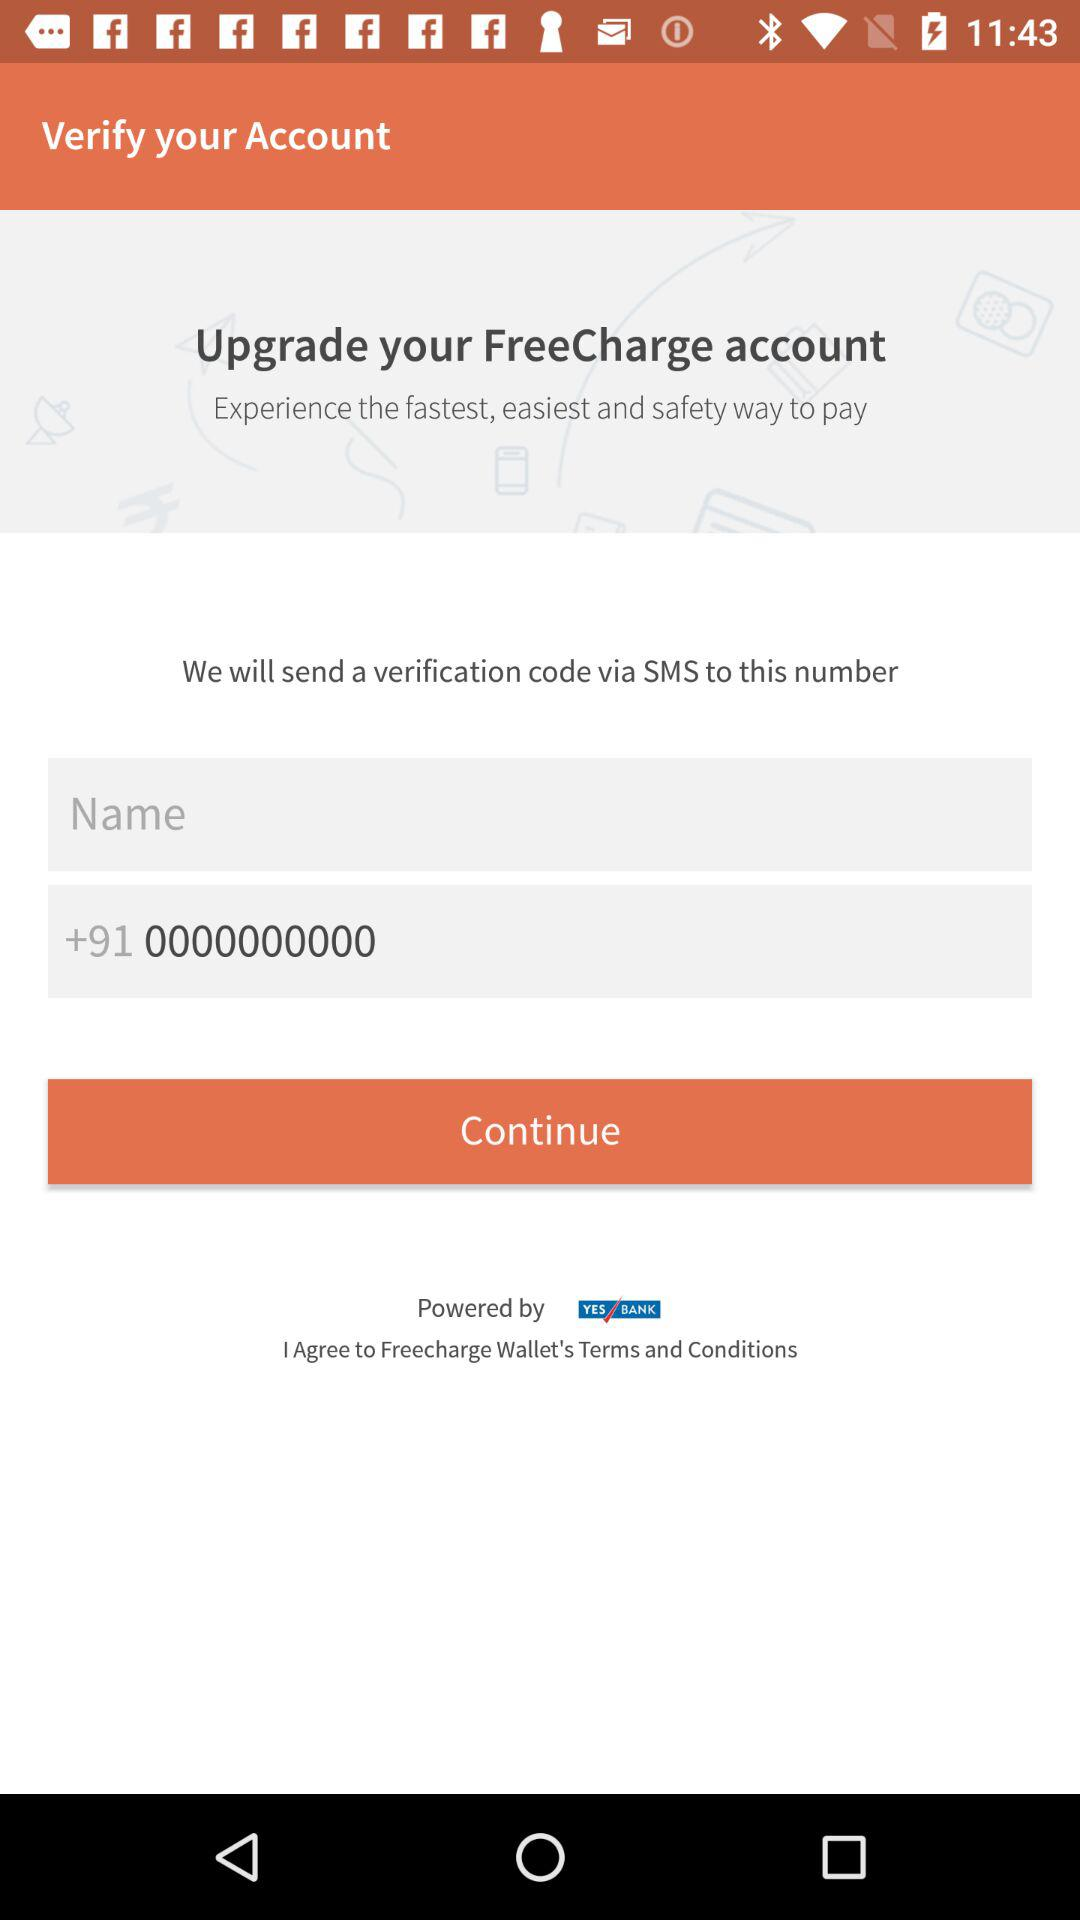What is the entered name?
When the provided information is insufficient, respond with <no answer>. <no answer> 